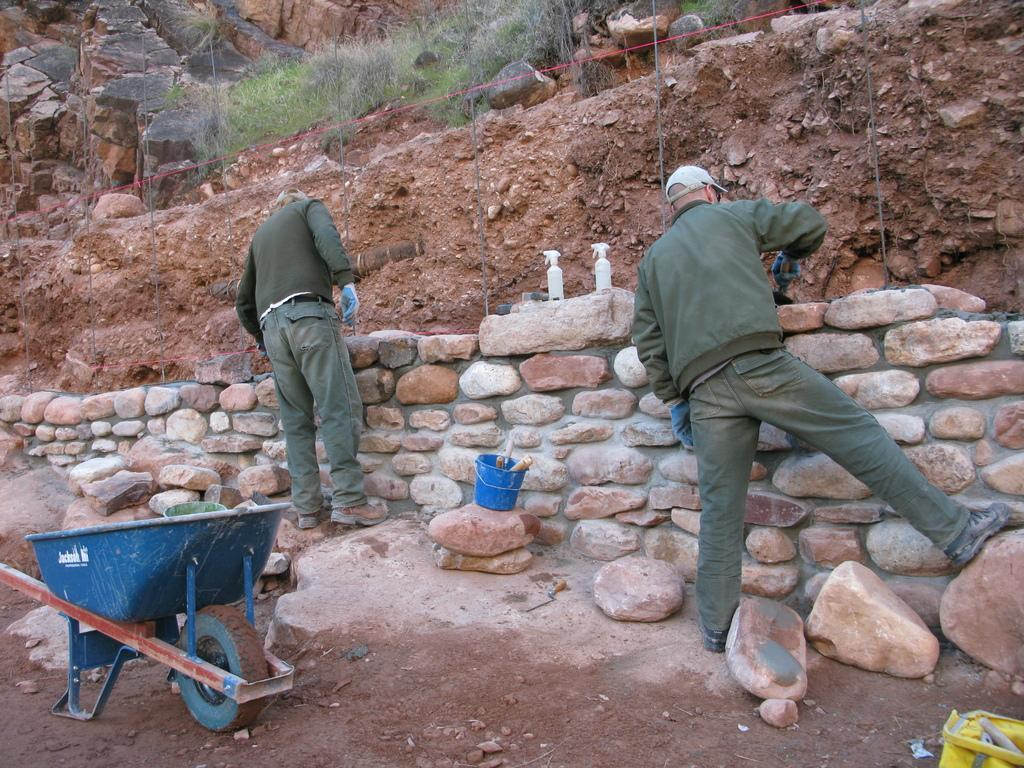How many people are in the image? There are two persons in the image. What are the persons doing in the image? The persons are constructing a stone wall. What can be seen on the left side of the image? There is a wheelbarrow on the left side of the image. What is visible at the top of the image? There are rocks and plants present at the top of the image. What type of skin care product is visible in the image? There is no skin care product present in the image. What role does the spoon play in the construction of the stone wall? There is no spoon present in the image, so it cannot play a role in the construction of the stone wall. 